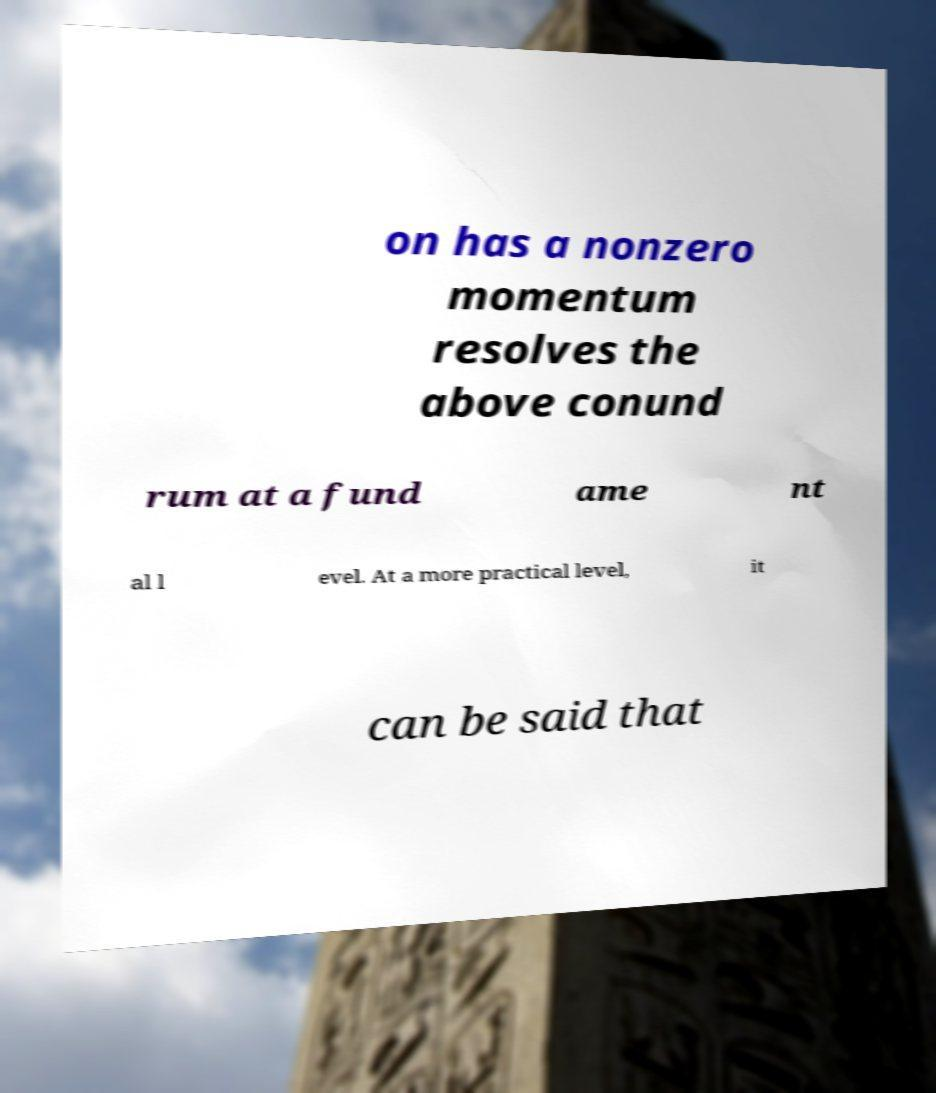Can you accurately transcribe the text from the provided image for me? on has a nonzero momentum resolves the above conund rum at a fund ame nt al l evel. At a more practical level, it can be said that 